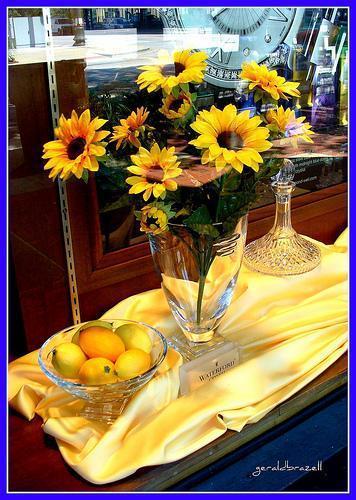How many sunflowers are pictured?
Give a very brief answer. 9. How many of the flowers are white?
Give a very brief answer. 0. 